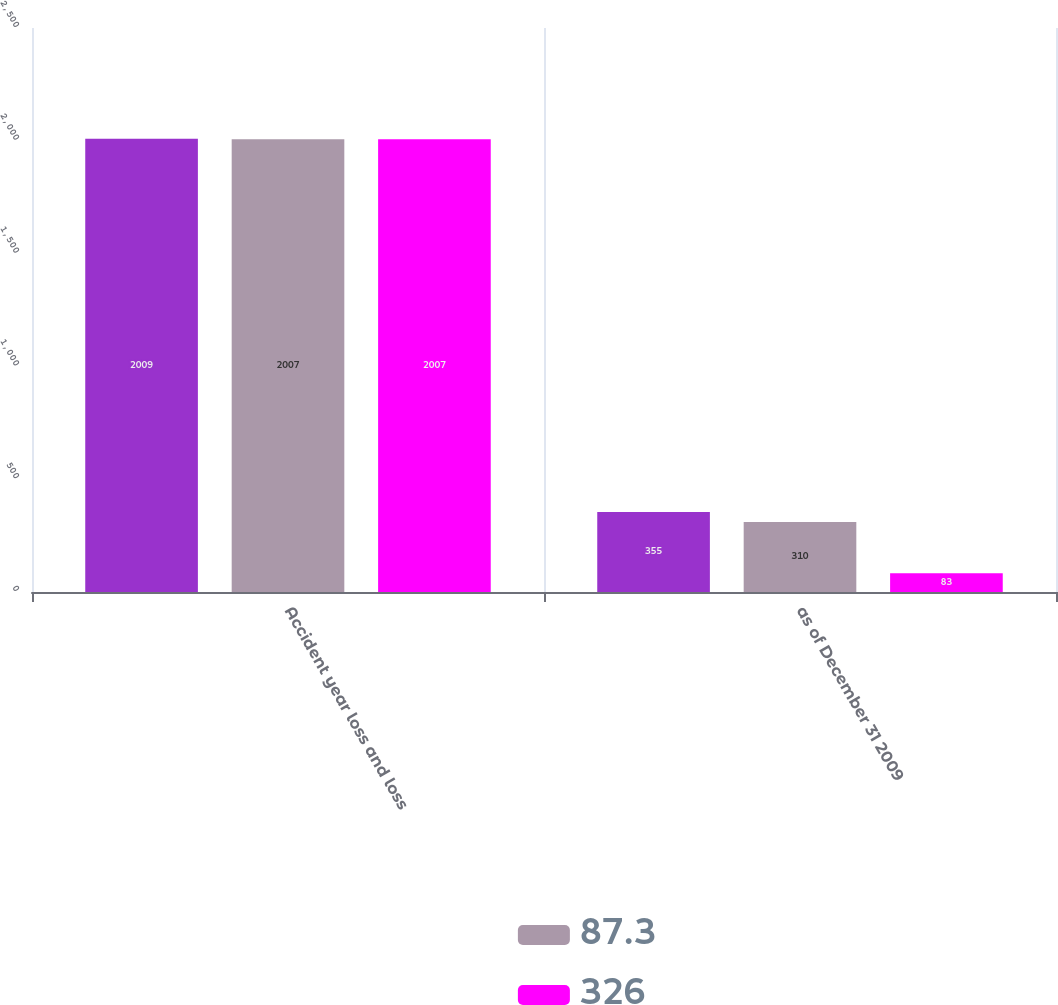Convert chart. <chart><loc_0><loc_0><loc_500><loc_500><stacked_bar_chart><ecel><fcel>Accident year loss and loss<fcel>as of December 31 2009<nl><fcel>nan<fcel>2009<fcel>355<nl><fcel>87.3<fcel>2007<fcel>310<nl><fcel>326<fcel>2007<fcel>83<nl></chart> 